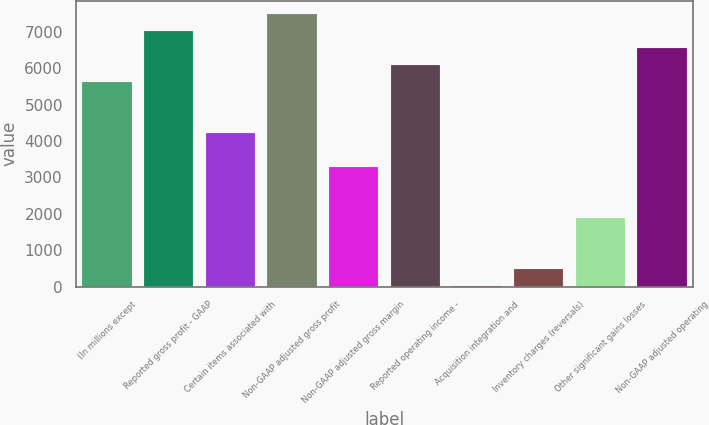Convert chart. <chart><loc_0><loc_0><loc_500><loc_500><bar_chart><fcel>(In millions except<fcel>Reported gross profit - GAAP<fcel>Certain items associated with<fcel>Non-GAAP adjusted gross profit<fcel>Non-GAAP adjusted gross margin<fcel>Reported operating income -<fcel>Acquisition integration and<fcel>Inventory charges (reversals)<fcel>Other significant gains losses<fcel>Non-GAAP adjusted operating<nl><fcel>5610.8<fcel>7013<fcel>4208.6<fcel>7480.4<fcel>3273.8<fcel>6078.2<fcel>2<fcel>469.4<fcel>1871.6<fcel>6545.6<nl></chart> 